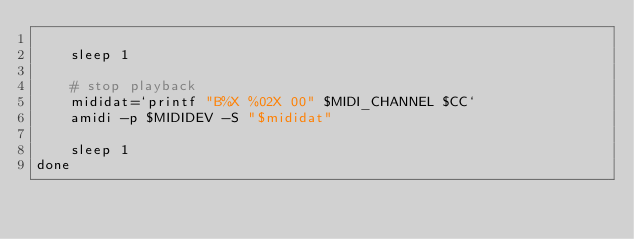Convert code to text. <code><loc_0><loc_0><loc_500><loc_500><_Bash_>
    sleep 1

    # stop playback
    mididat=`printf "B%X %02X 00" $MIDI_CHANNEL $CC`  
    amidi -p $MIDIDEV -S "$mididat"

    sleep 1
done

</code> 